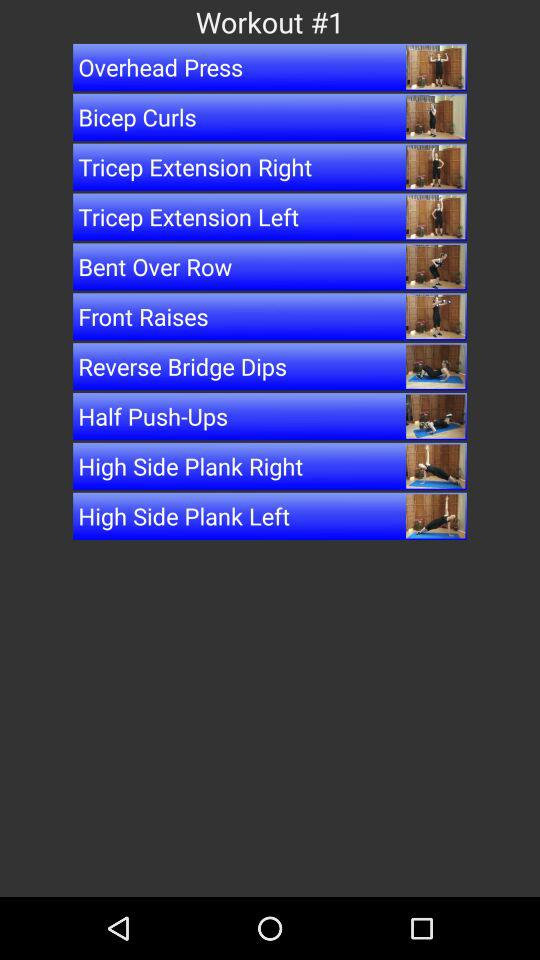How many exercises are in the workout?
Answer the question using a single word or phrase. 10 